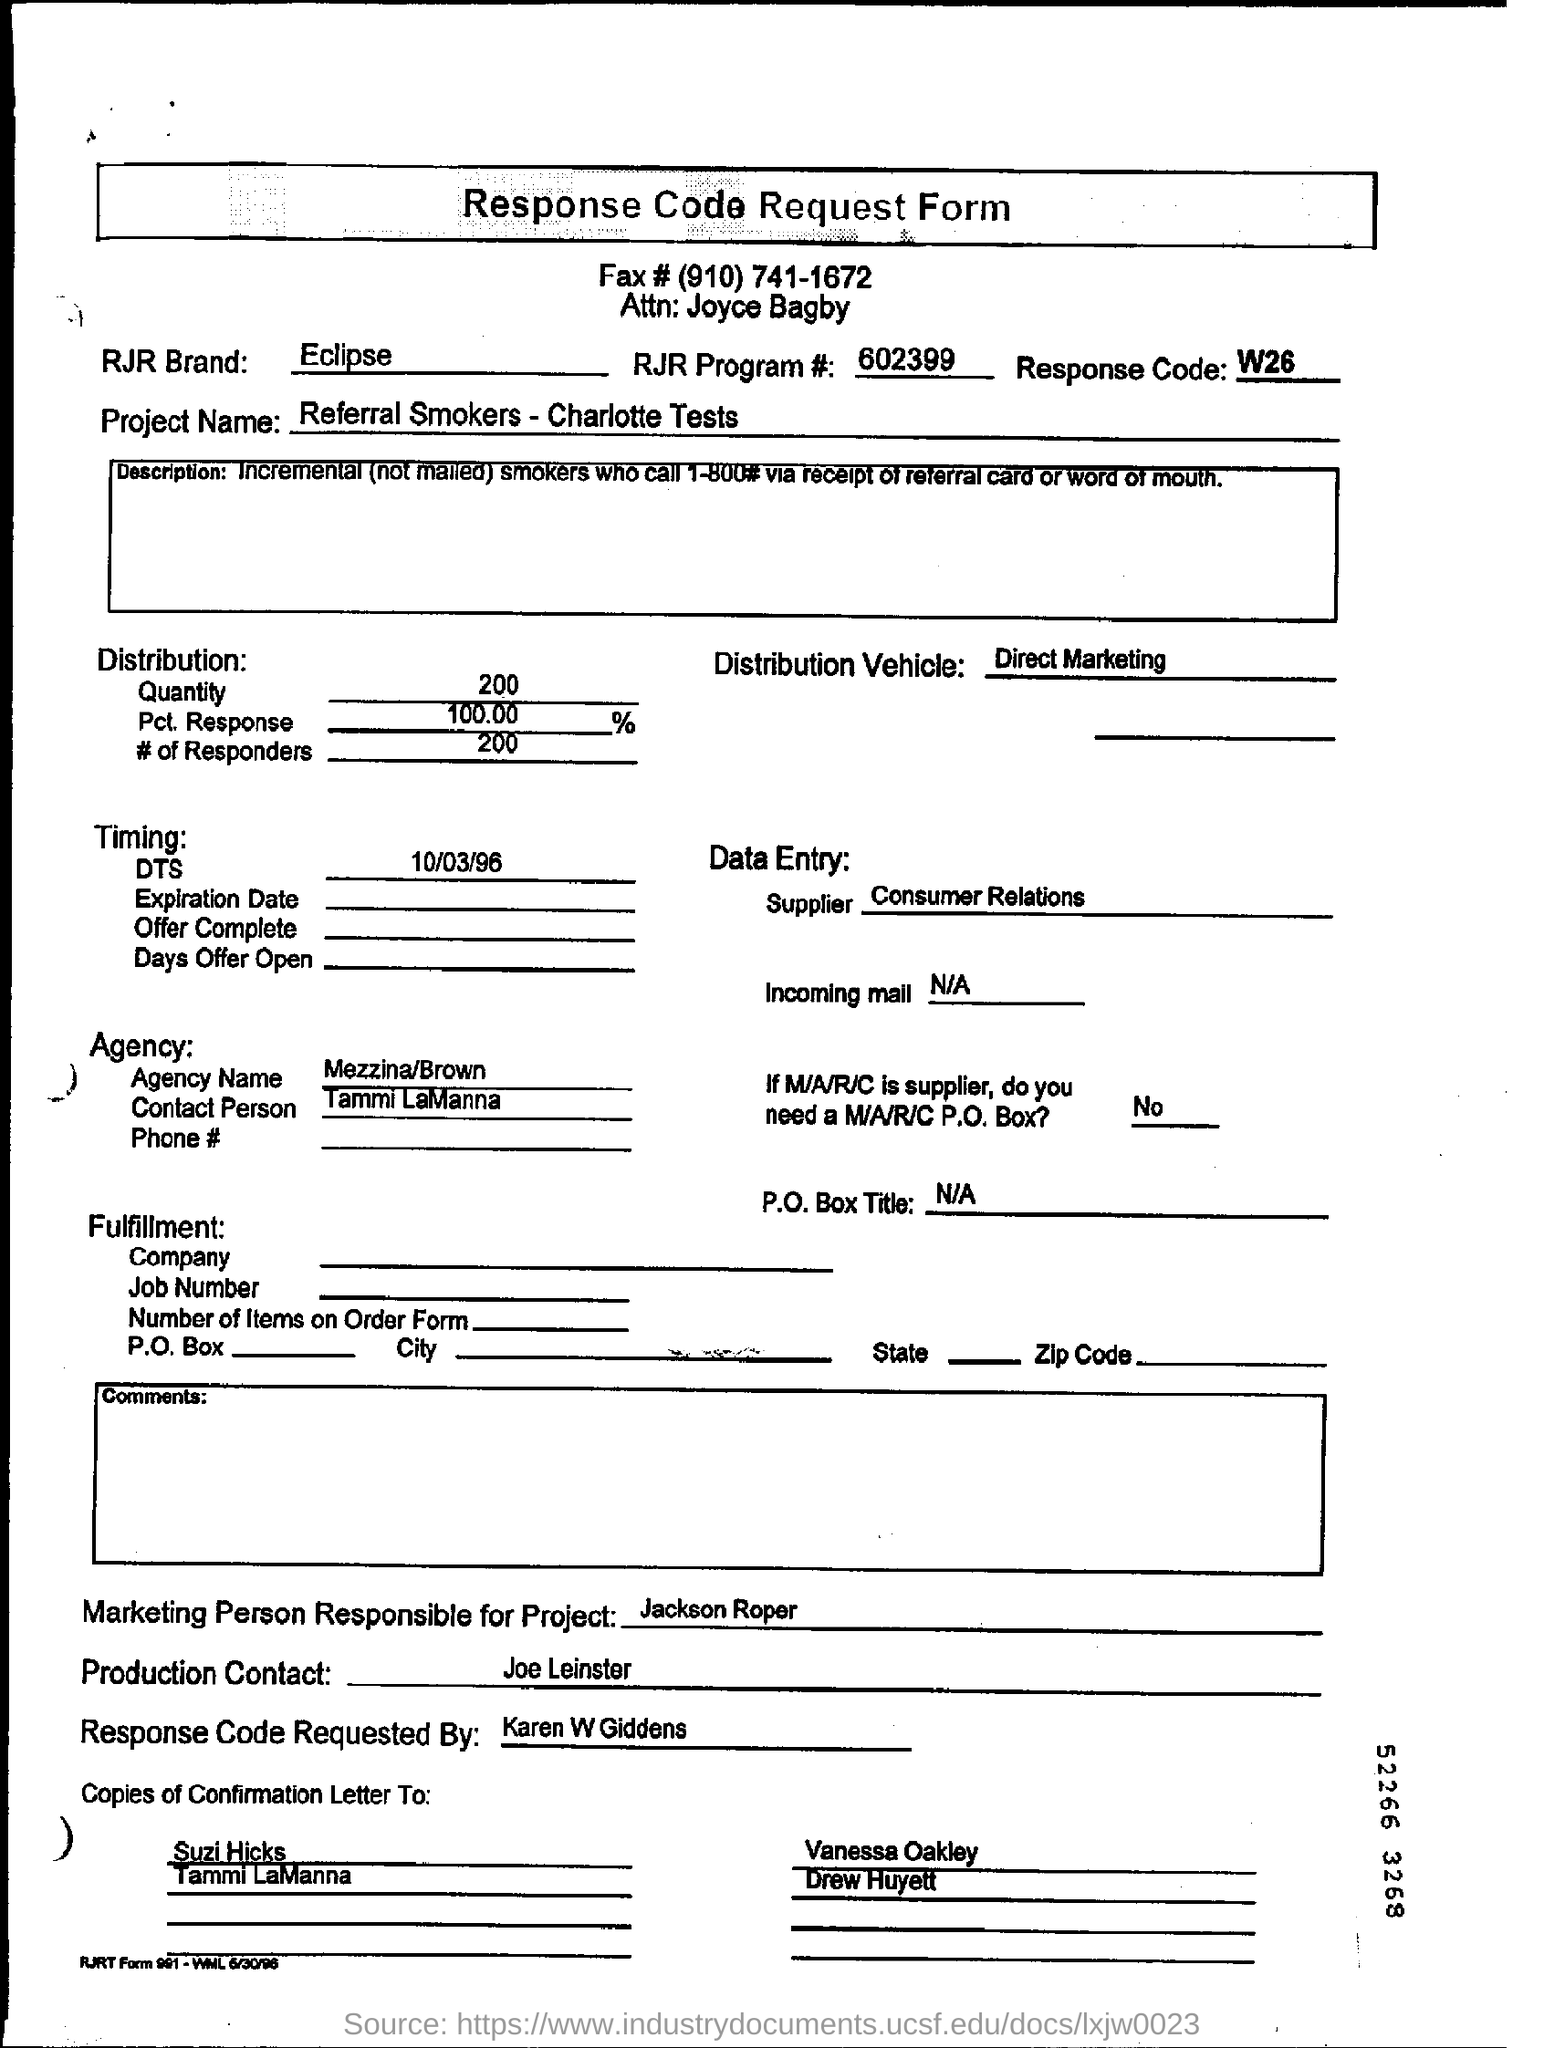What kind of form is this ?
Provide a short and direct response. Response Code Request Form. What is the project name mentioned in the request form?
Ensure brevity in your answer.  Referral Smokers-Charlotte Tests. Who is the Marketing Person responsible for Project?
Offer a terse response. Jackson Roper. What is the Response Code Assigned?
Offer a terse response. W26. What is the DTS Date mentioned in this document?
Provide a succinct answer. 10/03/96. What is the Pct. Response in distribution?
Your response must be concise. 100.00  %. Who requested the Response Code?
Provide a succinct answer. Karen W Giddens. What is the RJR Program# ?
Your answer should be compact. 602399. 